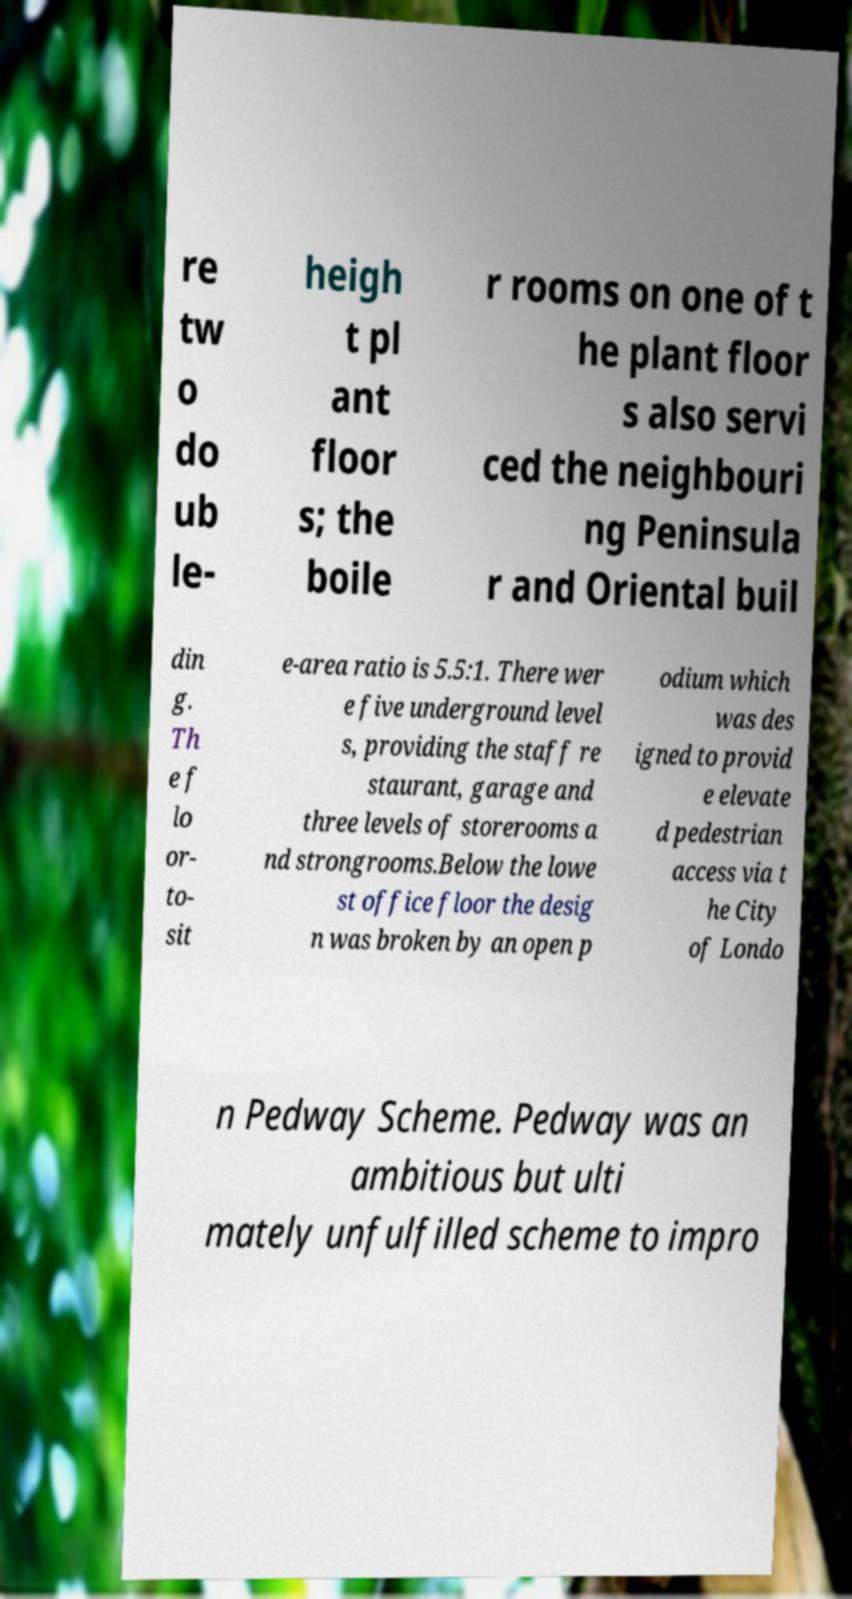Could you extract and type out the text from this image? re tw o do ub le- heigh t pl ant floor s; the boile r rooms on one of t he plant floor s also servi ced the neighbouri ng Peninsula r and Oriental buil din g. Th e f lo or- to- sit e-area ratio is 5.5:1. There wer e five underground level s, providing the staff re staurant, garage and three levels of storerooms a nd strongrooms.Below the lowe st office floor the desig n was broken by an open p odium which was des igned to provid e elevate d pedestrian access via t he City of Londo n Pedway Scheme. Pedway was an ambitious but ulti mately unfulfilled scheme to impro 